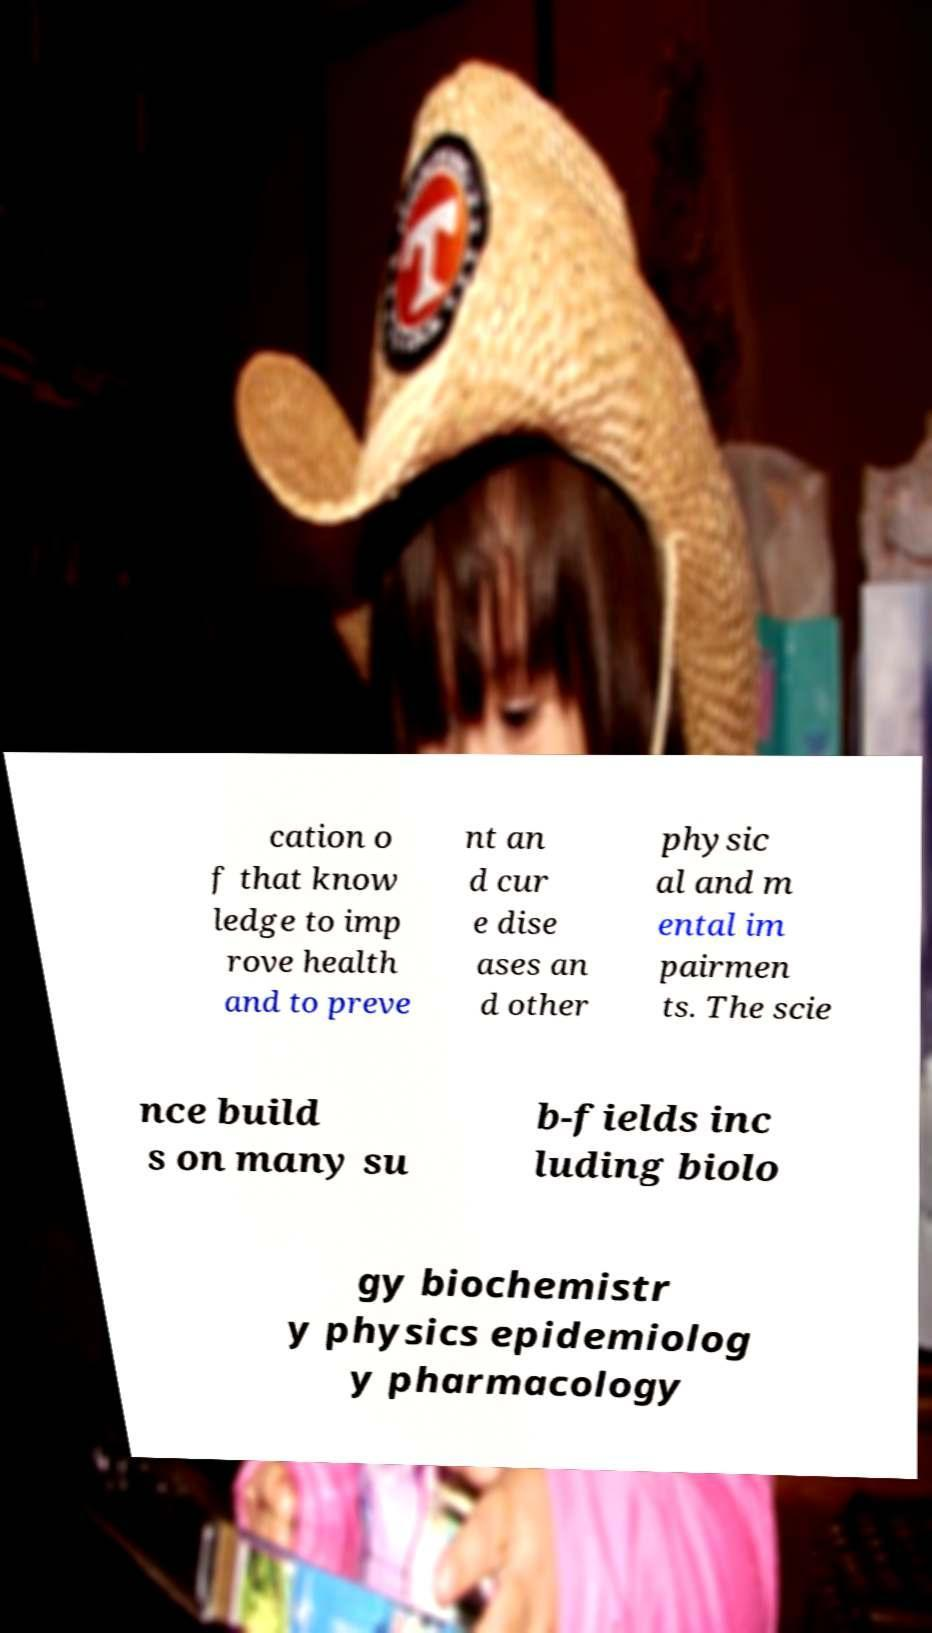Please read and relay the text visible in this image. What does it say? cation o f that know ledge to imp rove health and to preve nt an d cur e dise ases an d other physic al and m ental im pairmen ts. The scie nce build s on many su b-fields inc luding biolo gy biochemistr y physics epidemiolog y pharmacology 